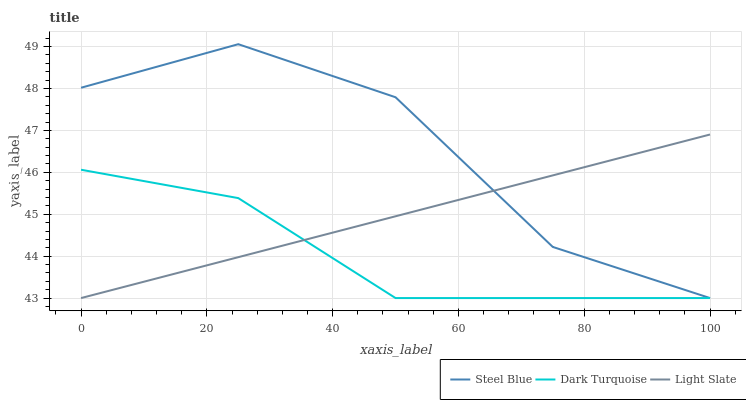Does Steel Blue have the minimum area under the curve?
Answer yes or no. No. Does Dark Turquoise have the maximum area under the curve?
Answer yes or no. No. Is Dark Turquoise the smoothest?
Answer yes or no. No. Is Dark Turquoise the roughest?
Answer yes or no. No. Does Dark Turquoise have the highest value?
Answer yes or no. No. 